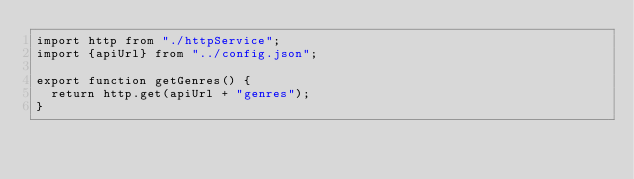Convert code to text. <code><loc_0><loc_0><loc_500><loc_500><_JavaScript_>import http from "./httpService";
import {apiUrl} from "../config.json";

export function getGenres() {
  return http.get(apiUrl + "genres");
}
</code> 